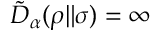Convert formula to latex. <formula><loc_0><loc_0><loc_500><loc_500>\tilde { D } _ { \alpha } ( \rho \| \sigma ) = \infty</formula> 